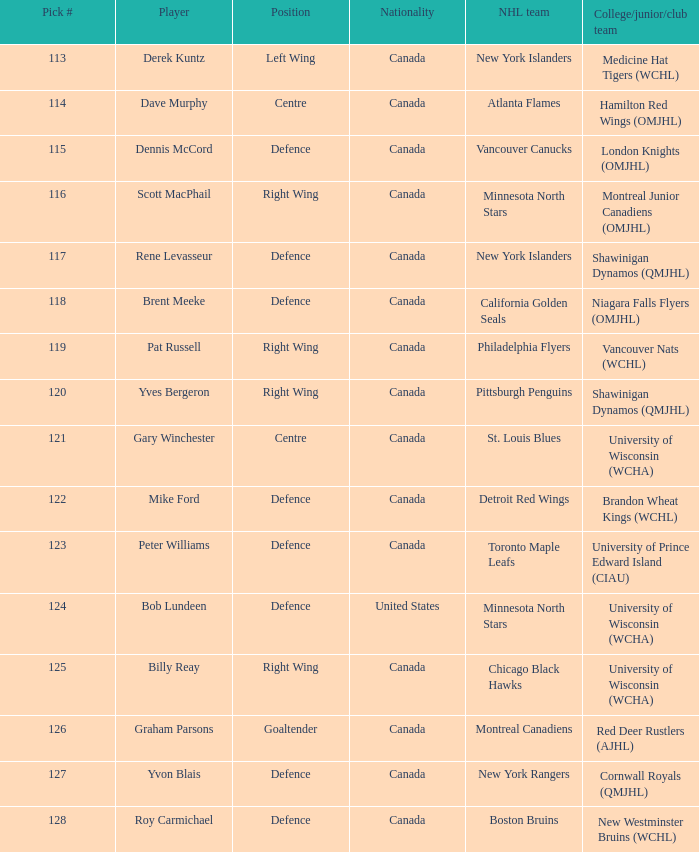State the job for option 12 Defence. 